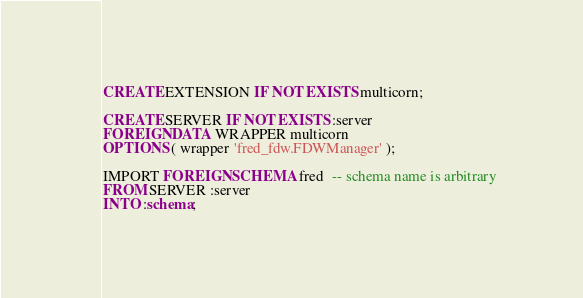Convert code to text. <code><loc_0><loc_0><loc_500><loc_500><_SQL_>CREATE EXTENSION IF NOT EXISTS multicorn;

CREATE SERVER IF NOT EXISTS :server
FOREIGN DATA WRAPPER multicorn
OPTIONS ( wrapper 'fred_fdw.FDWManager' );

IMPORT FOREIGN SCHEMA fred  -- schema name is arbitrary
FROM SERVER :server
INTO :schema;
</code> 